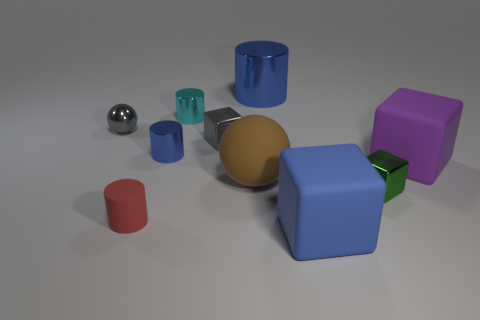What can you tell me about the colors of the objects? Do they follow a pattern? The objects in the image present a variety of colors, including blue, teal, purple, gold, red, and silver. There doesn't seem to be a deliberate pattern to the colors; they're distributed randomly across the scene. The objects are matte, with the exception of the reflective metallic sphere. 